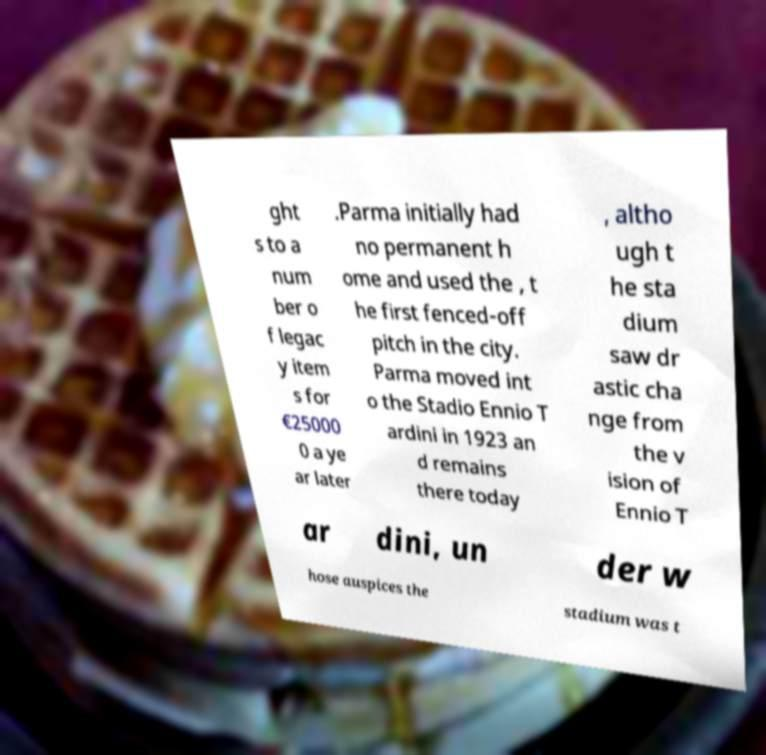Please identify and transcribe the text found in this image. ght s to a num ber o f legac y item s for €25000 0 a ye ar later .Parma initially had no permanent h ome and used the , t he first fenced-off pitch in the city. Parma moved int o the Stadio Ennio T ardini in 1923 an d remains there today , altho ugh t he sta dium saw dr astic cha nge from the v ision of Ennio T ar dini, un der w hose auspices the stadium was t 